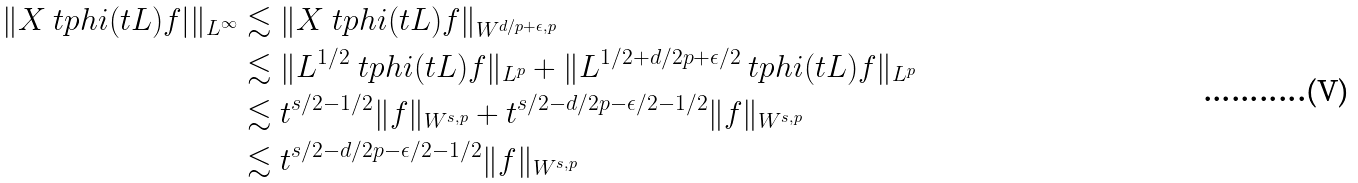<formula> <loc_0><loc_0><loc_500><loc_500>\| X \ t p h i ( t L ) f | \| _ { L ^ { \infty } } & \lesssim \| X \ t p h i ( t L ) f \| _ { W ^ { d / p + \epsilon , p } } \\ & \lesssim \| L ^ { 1 / 2 } \ t p h i ( t L ) f \| _ { L ^ { p } } + \| L ^ { 1 / 2 + d / { 2 p } + \epsilon / 2 } \ t p h i ( t L ) f \| _ { L ^ { p } } \\ & \lesssim t ^ { s / 2 - 1 / 2 } \| f \| _ { W ^ { s , p } } + t ^ { s / 2 - d / { 2 p } - \epsilon / 2 - 1 / 2 } \| f \| _ { W ^ { s , p } } \\ & \lesssim t ^ { s / 2 - d / { 2 p } - \epsilon / 2 - 1 / 2 } \| f \| _ { W ^ { s , p } }</formula> 